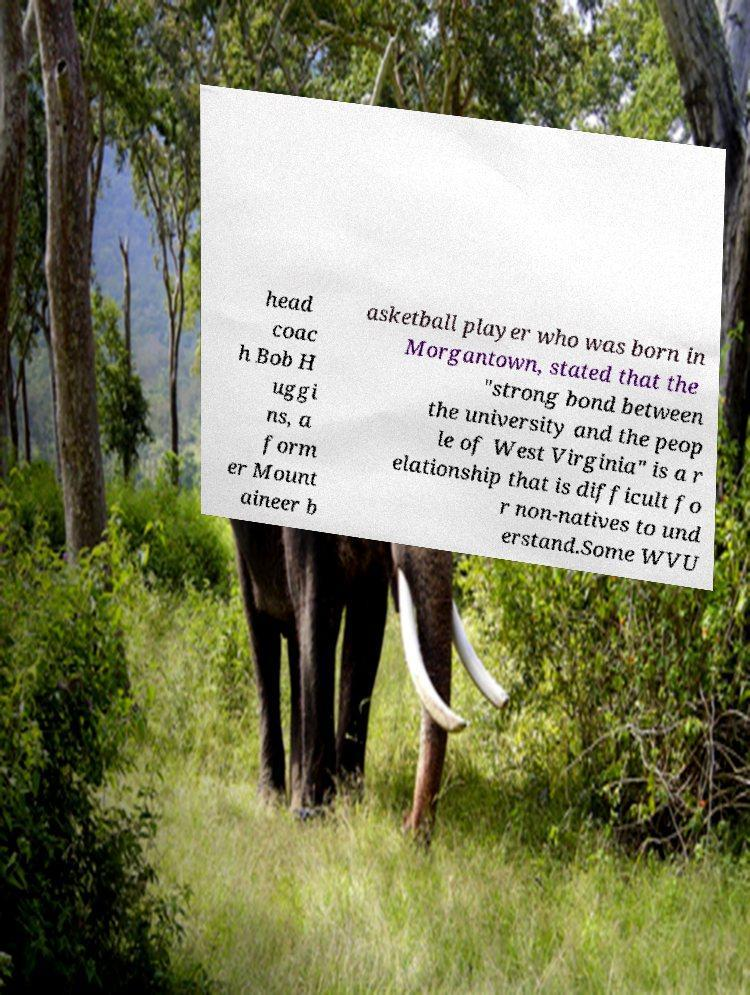Could you extract and type out the text from this image? head coac h Bob H uggi ns, a form er Mount aineer b asketball player who was born in Morgantown, stated that the "strong bond between the university and the peop le of West Virginia" is a r elationship that is difficult fo r non-natives to und erstand.Some WVU 